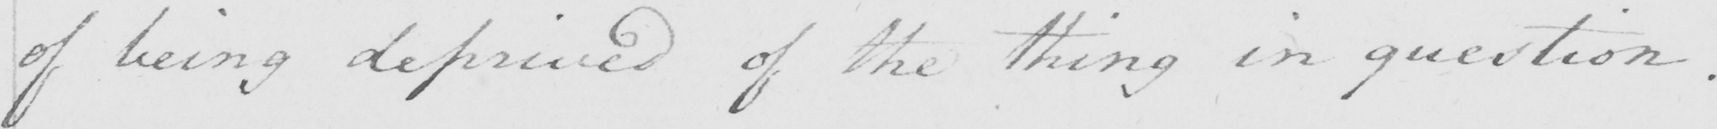Please provide the text content of this handwritten line. of being deprived of the thing in question . 